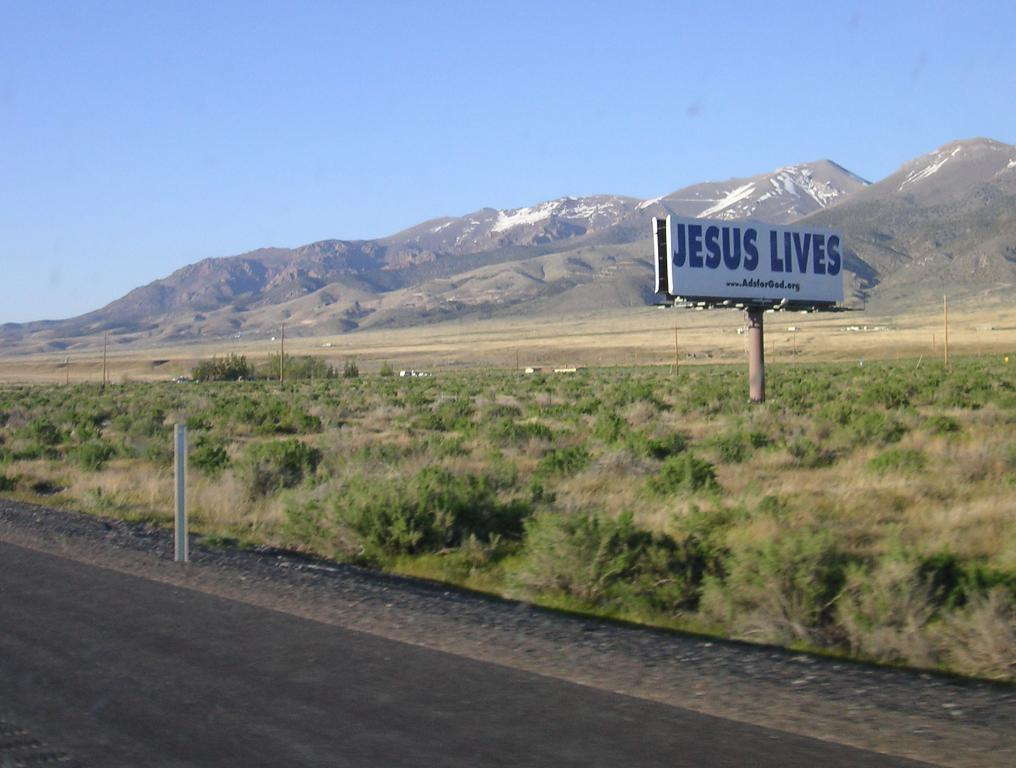<image>
Relay a brief, clear account of the picture shown. Jesus Lives banner out in a field by a road way. 